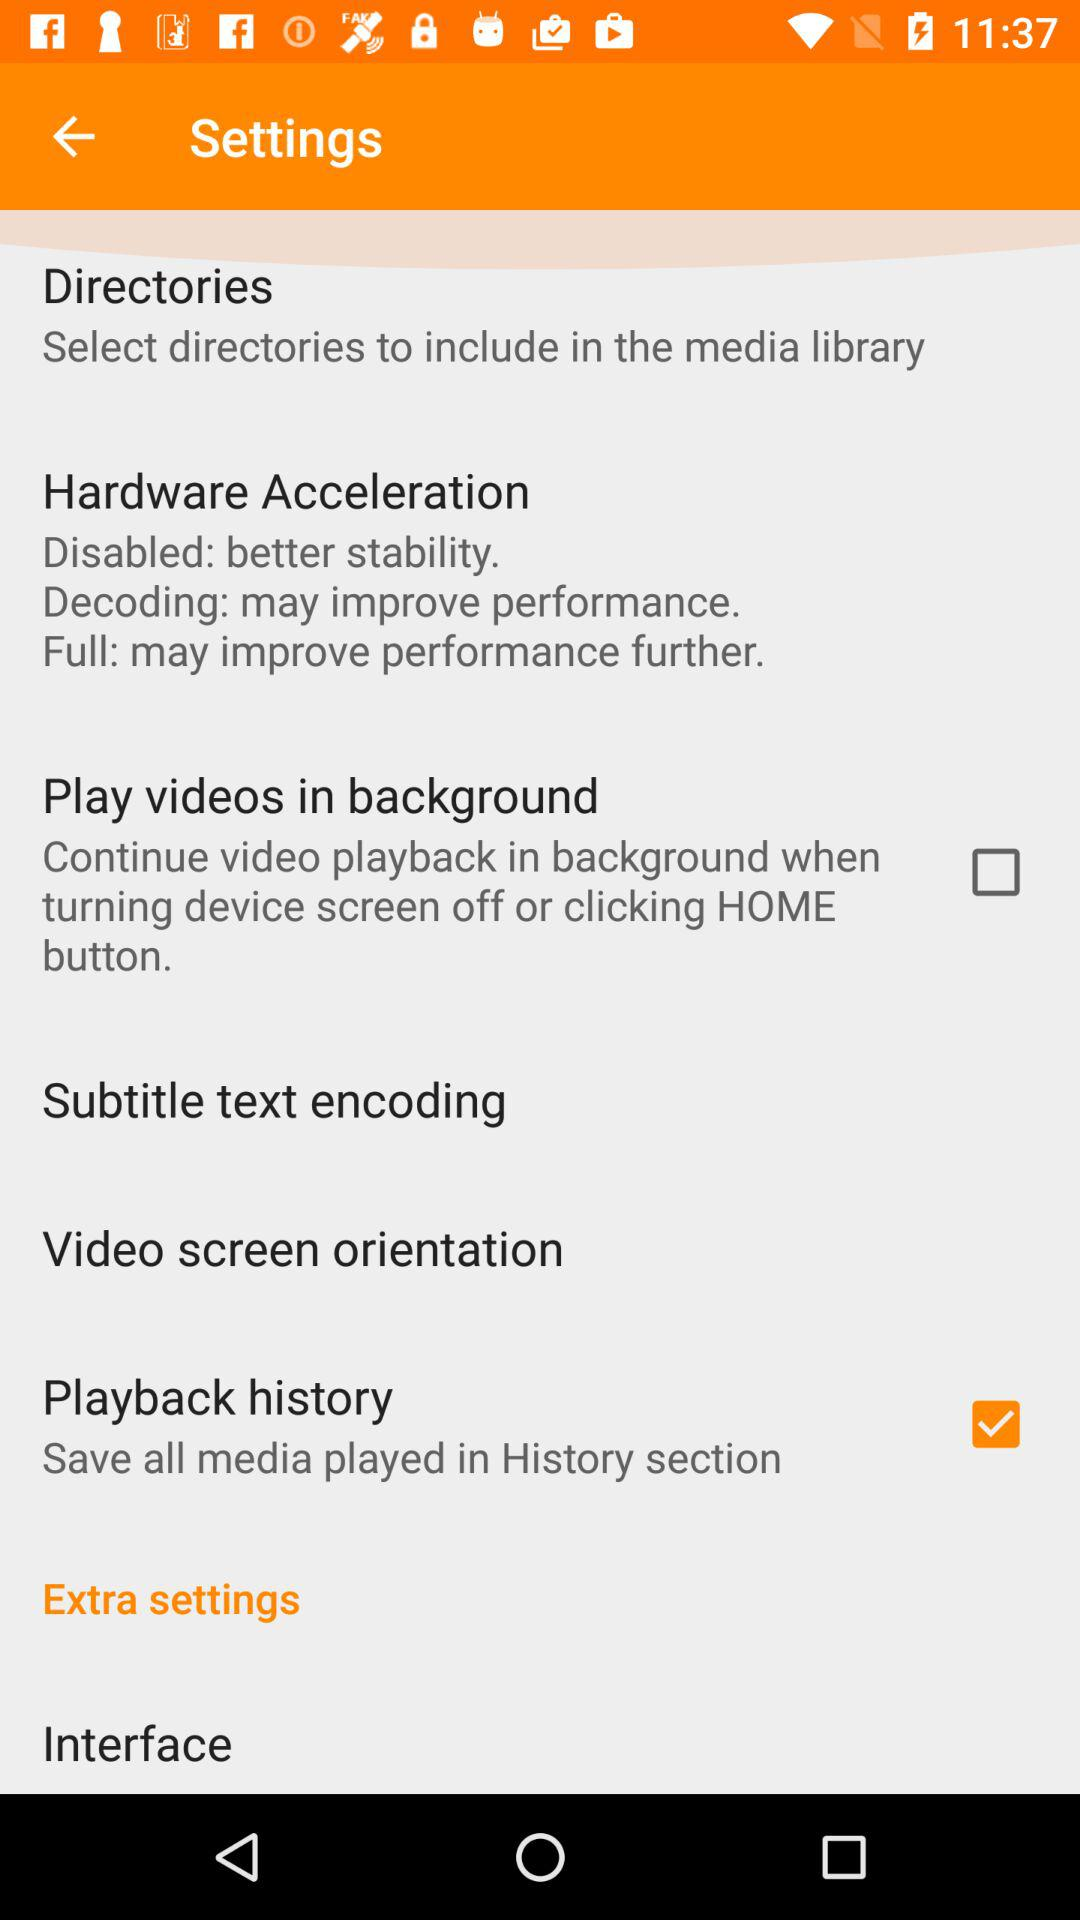Which option is not marked as checked? The option that is not marked as checked is "Play videos in background". 